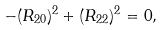<formula> <loc_0><loc_0><loc_500><loc_500>- ( R _ { 2 0 } ) ^ { 2 } + ( R _ { 2 2 } ) ^ { 2 } = 0 ,</formula> 